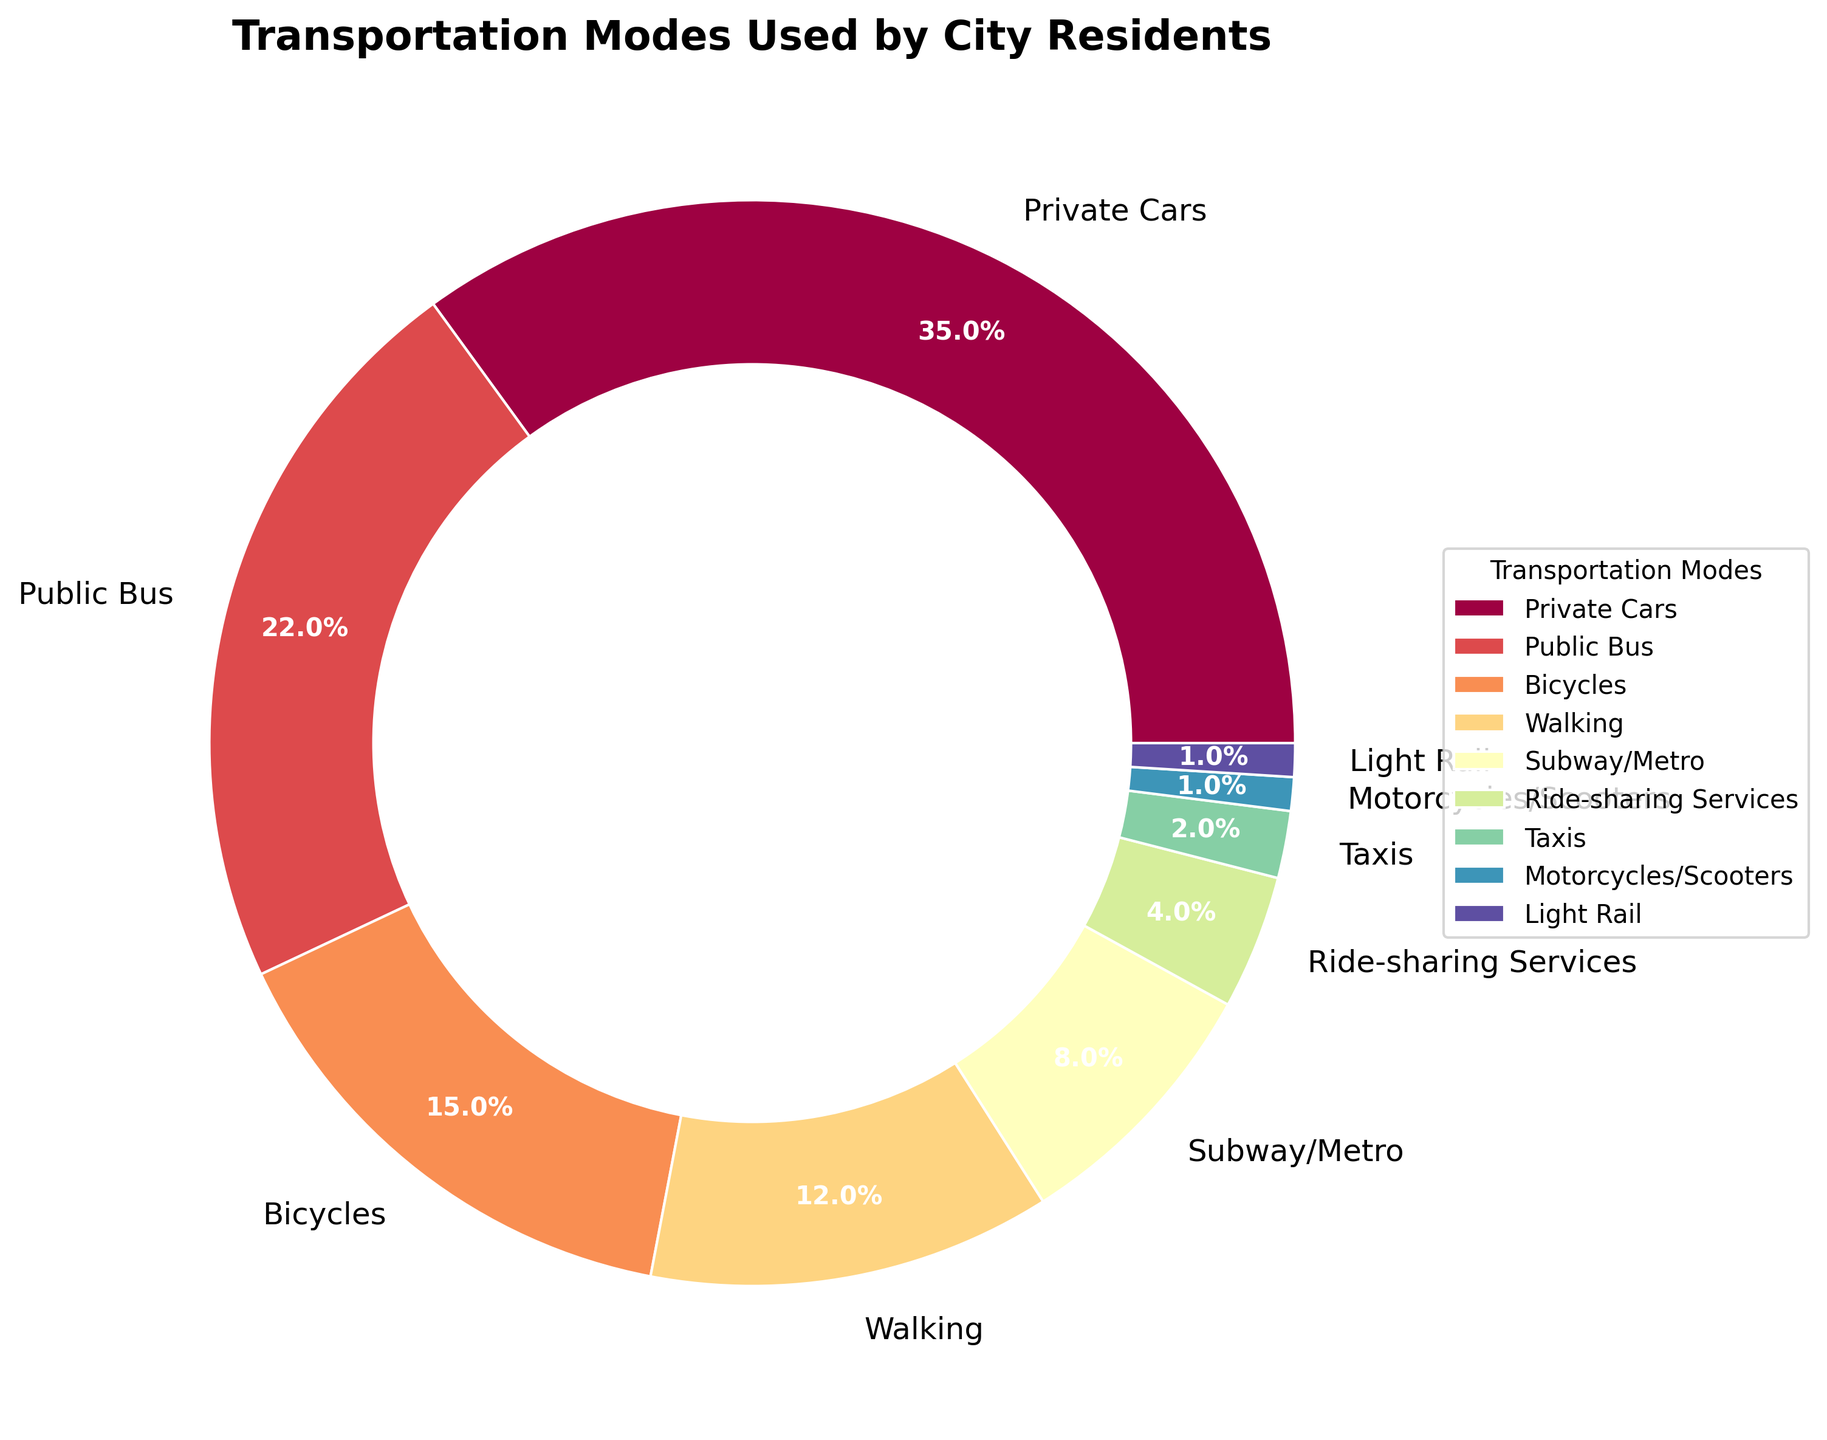What is the largest mode of transportation used by city residents? The largest segment on the pie chart represents Private Cars with 35%.
Answer: Private Cars Which mode of transportation has the smallest percentage? The smallest segments on the pie chart represent Motorcycles/Scooters and Light Rail, each with 1%.
Answer: Motorcycles/Scooters, Light Rail How much more popular are Private Cars compared to Bicycles? Private Cars have 35% and Bicycles have 15%. Calculate the difference: 35% - 15% = 20%.
Answer: 20% Are Public Bus and Walking combined more popular than Private Cars? Public Bus is 22% and Walking is 12%. Combined, they are 22% + 12% = 34%. Private Cars are 35%. Therefore, Private Cars are still more popular.
Answer: No What is the combined percentage of residents using Ride-sharing Services and Taxis? Ride-sharing Services have 4% and Taxis have 2%. Combined, they are 4% + 2% = 6%.
Answer: 6% Which transportation mode is exactly half as popular as the Public Bus? Public Bus has 22%. Half of 22% is 11%. The closest mode with 12% is Walking.
Answer: Walking List the modes of transportation that have a percentage of less than 10%. From the chart, the modes with percentages less than 10% are Subway/Metro (8%), Ride-sharing Services (4%), Taxis (2%), Motorcycles/Scooters (1%), and Light Rail (1%).
Answer: Subway/Metro, Ride-sharing Services, Taxis, Motorcycles/Scooters, Light Rail If the total number of residents is one million, how many residents use Bicycles? Bicycles account for 15%. To find the number of residents, multiply 0.15 by one million: 0.15 * 1,000,000 = 150,000.
Answer: 150,000 